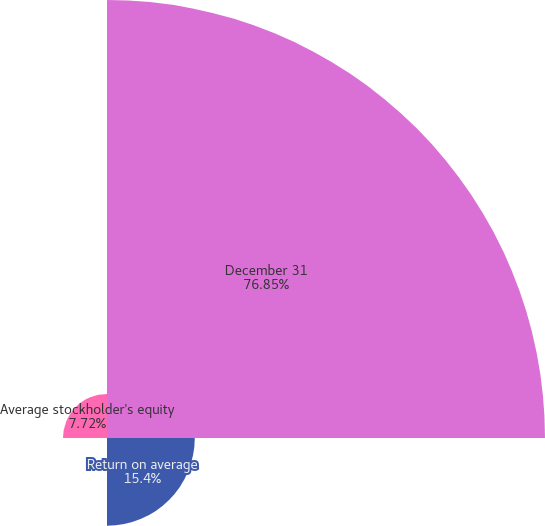<chart> <loc_0><loc_0><loc_500><loc_500><pie_chart><fcel>December 31<fcel>Return on average<fcel>Return on average total assets<fcel>Average stockholder's equity<nl><fcel>76.85%<fcel>15.4%<fcel>0.03%<fcel>7.72%<nl></chart> 